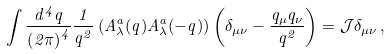Convert formula to latex. <formula><loc_0><loc_0><loc_500><loc_500>\int \frac { d ^ { 4 } q } { \left ( 2 \pi \right ) ^ { 4 } } \frac { 1 } { q ^ { 2 } } \left ( A _ { \lambda } ^ { a } ( q ) A _ { \lambda } ^ { a } ( - q ) \right ) \left ( \delta _ { \mu \nu } - \frac { q _ { \mu } q _ { \nu } } { q ^ { 2 } } \right ) = \mathcal { J } \delta _ { \mu \nu } \, ,</formula> 